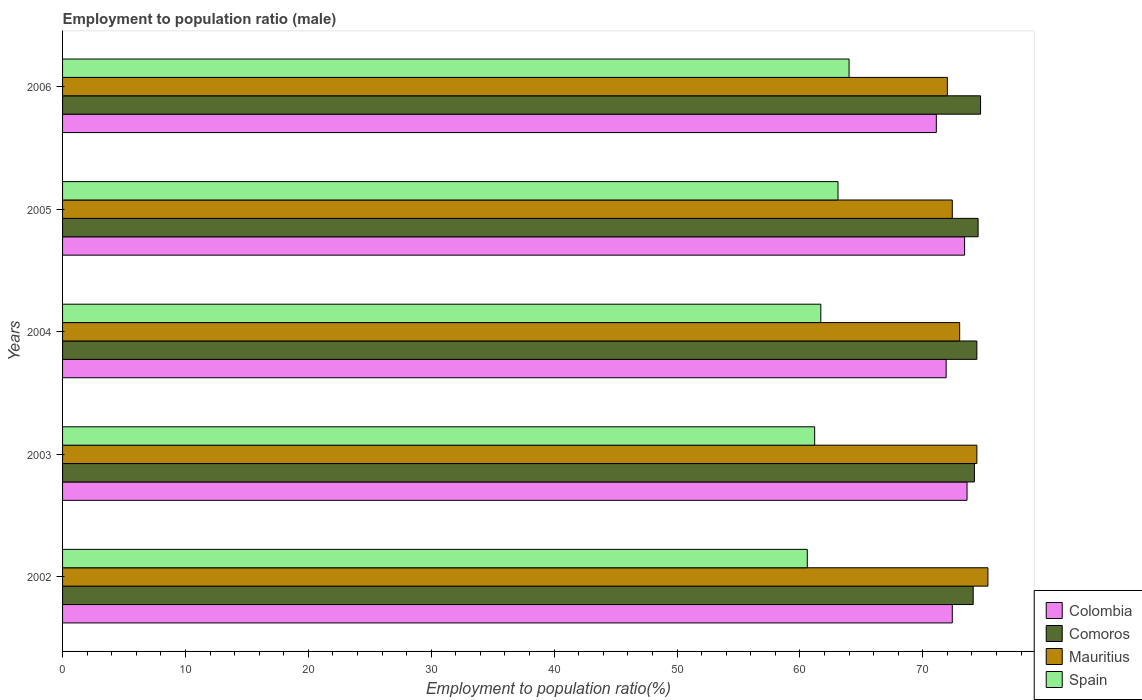How many different coloured bars are there?
Offer a terse response. 4. Are the number of bars per tick equal to the number of legend labels?
Provide a short and direct response. Yes. How many bars are there on the 2nd tick from the bottom?
Keep it short and to the point. 4. What is the label of the 1st group of bars from the top?
Provide a succinct answer. 2006. What is the employment to population ratio in Spain in 2006?
Your answer should be compact. 64. Across all years, what is the maximum employment to population ratio in Colombia?
Keep it short and to the point. 73.6. Across all years, what is the minimum employment to population ratio in Comoros?
Your answer should be compact. 74.1. In which year was the employment to population ratio in Colombia minimum?
Your response must be concise. 2006. What is the total employment to population ratio in Comoros in the graph?
Offer a very short reply. 371.9. What is the difference between the employment to population ratio in Comoros in 2004 and that in 2005?
Ensure brevity in your answer.  -0.1. What is the difference between the employment to population ratio in Mauritius in 2003 and the employment to population ratio in Spain in 2002?
Your answer should be compact. 13.8. What is the average employment to population ratio in Mauritius per year?
Your response must be concise. 73.42. In the year 2003, what is the difference between the employment to population ratio in Spain and employment to population ratio in Mauritius?
Provide a short and direct response. -13.2. What is the ratio of the employment to population ratio in Colombia in 2005 to that in 2006?
Keep it short and to the point. 1.03. Is the employment to population ratio in Mauritius in 2002 less than that in 2005?
Your answer should be compact. No. Is the difference between the employment to population ratio in Spain in 2004 and 2005 greater than the difference between the employment to population ratio in Mauritius in 2004 and 2005?
Provide a succinct answer. No. What is the difference between the highest and the second highest employment to population ratio in Mauritius?
Provide a succinct answer. 0.9. What is the difference between the highest and the lowest employment to population ratio in Comoros?
Your response must be concise. 0.6. Is it the case that in every year, the sum of the employment to population ratio in Mauritius and employment to population ratio in Spain is greater than the sum of employment to population ratio in Colombia and employment to population ratio in Comoros?
Give a very brief answer. No. What does the 3rd bar from the top in 2006 represents?
Offer a very short reply. Comoros. What does the 4th bar from the bottom in 2005 represents?
Provide a succinct answer. Spain. Are the values on the major ticks of X-axis written in scientific E-notation?
Provide a short and direct response. No. What is the title of the graph?
Your answer should be compact. Employment to population ratio (male). Does "Nigeria" appear as one of the legend labels in the graph?
Give a very brief answer. No. What is the label or title of the X-axis?
Your answer should be very brief. Employment to population ratio(%). What is the Employment to population ratio(%) in Colombia in 2002?
Offer a very short reply. 72.4. What is the Employment to population ratio(%) of Comoros in 2002?
Offer a very short reply. 74.1. What is the Employment to population ratio(%) in Mauritius in 2002?
Your answer should be compact. 75.3. What is the Employment to population ratio(%) in Spain in 2002?
Provide a short and direct response. 60.6. What is the Employment to population ratio(%) in Colombia in 2003?
Ensure brevity in your answer.  73.6. What is the Employment to population ratio(%) in Comoros in 2003?
Your response must be concise. 74.2. What is the Employment to population ratio(%) in Mauritius in 2003?
Make the answer very short. 74.4. What is the Employment to population ratio(%) in Spain in 2003?
Keep it short and to the point. 61.2. What is the Employment to population ratio(%) of Colombia in 2004?
Your response must be concise. 71.9. What is the Employment to population ratio(%) in Comoros in 2004?
Make the answer very short. 74.4. What is the Employment to population ratio(%) in Mauritius in 2004?
Make the answer very short. 73. What is the Employment to population ratio(%) of Spain in 2004?
Ensure brevity in your answer.  61.7. What is the Employment to population ratio(%) of Colombia in 2005?
Provide a succinct answer. 73.4. What is the Employment to population ratio(%) of Comoros in 2005?
Provide a short and direct response. 74.5. What is the Employment to population ratio(%) in Mauritius in 2005?
Keep it short and to the point. 72.4. What is the Employment to population ratio(%) of Spain in 2005?
Offer a very short reply. 63.1. What is the Employment to population ratio(%) in Colombia in 2006?
Your response must be concise. 71.1. What is the Employment to population ratio(%) in Comoros in 2006?
Your answer should be very brief. 74.7. What is the Employment to population ratio(%) of Mauritius in 2006?
Your response must be concise. 72. Across all years, what is the maximum Employment to population ratio(%) of Colombia?
Provide a short and direct response. 73.6. Across all years, what is the maximum Employment to population ratio(%) in Comoros?
Make the answer very short. 74.7. Across all years, what is the maximum Employment to population ratio(%) in Mauritius?
Offer a very short reply. 75.3. Across all years, what is the minimum Employment to population ratio(%) of Colombia?
Keep it short and to the point. 71.1. Across all years, what is the minimum Employment to population ratio(%) of Comoros?
Ensure brevity in your answer.  74.1. Across all years, what is the minimum Employment to population ratio(%) of Spain?
Your answer should be compact. 60.6. What is the total Employment to population ratio(%) in Colombia in the graph?
Provide a short and direct response. 362.4. What is the total Employment to population ratio(%) in Comoros in the graph?
Provide a succinct answer. 371.9. What is the total Employment to population ratio(%) of Mauritius in the graph?
Offer a terse response. 367.1. What is the total Employment to population ratio(%) in Spain in the graph?
Provide a short and direct response. 310.6. What is the difference between the Employment to population ratio(%) in Comoros in 2002 and that in 2003?
Ensure brevity in your answer.  -0.1. What is the difference between the Employment to population ratio(%) of Mauritius in 2002 and that in 2003?
Offer a very short reply. 0.9. What is the difference between the Employment to population ratio(%) of Comoros in 2002 and that in 2004?
Give a very brief answer. -0.3. What is the difference between the Employment to population ratio(%) of Mauritius in 2002 and that in 2004?
Keep it short and to the point. 2.3. What is the difference between the Employment to population ratio(%) in Comoros in 2002 and that in 2005?
Offer a terse response. -0.4. What is the difference between the Employment to population ratio(%) of Mauritius in 2002 and that in 2005?
Your response must be concise. 2.9. What is the difference between the Employment to population ratio(%) of Colombia in 2002 and that in 2006?
Make the answer very short. 1.3. What is the difference between the Employment to population ratio(%) in Spain in 2002 and that in 2006?
Ensure brevity in your answer.  -3.4. What is the difference between the Employment to population ratio(%) in Comoros in 2003 and that in 2005?
Keep it short and to the point. -0.3. What is the difference between the Employment to population ratio(%) in Comoros in 2003 and that in 2006?
Ensure brevity in your answer.  -0.5. What is the difference between the Employment to population ratio(%) in Colombia in 2004 and that in 2005?
Make the answer very short. -1.5. What is the difference between the Employment to population ratio(%) of Mauritius in 2004 and that in 2005?
Ensure brevity in your answer.  0.6. What is the difference between the Employment to population ratio(%) in Colombia in 2004 and that in 2006?
Offer a terse response. 0.8. What is the difference between the Employment to population ratio(%) in Comoros in 2004 and that in 2006?
Make the answer very short. -0.3. What is the difference between the Employment to population ratio(%) of Mauritius in 2004 and that in 2006?
Ensure brevity in your answer.  1. What is the difference between the Employment to population ratio(%) in Spain in 2004 and that in 2006?
Your answer should be very brief. -2.3. What is the difference between the Employment to population ratio(%) in Spain in 2005 and that in 2006?
Ensure brevity in your answer.  -0.9. What is the difference between the Employment to population ratio(%) of Comoros in 2002 and the Employment to population ratio(%) of Mauritius in 2003?
Offer a very short reply. -0.3. What is the difference between the Employment to population ratio(%) of Comoros in 2002 and the Employment to population ratio(%) of Spain in 2003?
Your answer should be very brief. 12.9. What is the difference between the Employment to population ratio(%) in Mauritius in 2002 and the Employment to population ratio(%) in Spain in 2003?
Your answer should be very brief. 14.1. What is the difference between the Employment to population ratio(%) in Colombia in 2002 and the Employment to population ratio(%) in Comoros in 2004?
Ensure brevity in your answer.  -2. What is the difference between the Employment to population ratio(%) of Colombia in 2002 and the Employment to population ratio(%) of Spain in 2004?
Your answer should be compact. 10.7. What is the difference between the Employment to population ratio(%) of Colombia in 2002 and the Employment to population ratio(%) of Mauritius in 2005?
Your answer should be compact. 0. What is the difference between the Employment to population ratio(%) in Colombia in 2002 and the Employment to population ratio(%) in Spain in 2005?
Offer a terse response. 9.3. What is the difference between the Employment to population ratio(%) in Mauritius in 2002 and the Employment to population ratio(%) in Spain in 2005?
Give a very brief answer. 12.2. What is the difference between the Employment to population ratio(%) in Colombia in 2002 and the Employment to population ratio(%) in Mauritius in 2006?
Provide a short and direct response. 0.4. What is the difference between the Employment to population ratio(%) of Comoros in 2002 and the Employment to population ratio(%) of Mauritius in 2006?
Give a very brief answer. 2.1. What is the difference between the Employment to population ratio(%) of Mauritius in 2002 and the Employment to population ratio(%) of Spain in 2006?
Your answer should be compact. 11.3. What is the difference between the Employment to population ratio(%) of Colombia in 2003 and the Employment to population ratio(%) of Comoros in 2004?
Provide a succinct answer. -0.8. What is the difference between the Employment to population ratio(%) of Colombia in 2003 and the Employment to population ratio(%) of Mauritius in 2004?
Give a very brief answer. 0.6. What is the difference between the Employment to population ratio(%) in Colombia in 2003 and the Employment to population ratio(%) in Spain in 2004?
Offer a very short reply. 11.9. What is the difference between the Employment to population ratio(%) in Comoros in 2003 and the Employment to population ratio(%) in Spain in 2004?
Offer a terse response. 12.5. What is the difference between the Employment to population ratio(%) of Colombia in 2003 and the Employment to population ratio(%) of Spain in 2005?
Give a very brief answer. 10.5. What is the difference between the Employment to population ratio(%) in Colombia in 2003 and the Employment to population ratio(%) in Mauritius in 2006?
Offer a very short reply. 1.6. What is the difference between the Employment to population ratio(%) of Comoros in 2003 and the Employment to population ratio(%) of Mauritius in 2006?
Keep it short and to the point. 2.2. What is the difference between the Employment to population ratio(%) in Comoros in 2003 and the Employment to population ratio(%) in Spain in 2006?
Provide a short and direct response. 10.2. What is the difference between the Employment to population ratio(%) of Mauritius in 2003 and the Employment to population ratio(%) of Spain in 2006?
Your answer should be very brief. 10.4. What is the difference between the Employment to population ratio(%) of Comoros in 2004 and the Employment to population ratio(%) of Mauritius in 2005?
Give a very brief answer. 2. What is the difference between the Employment to population ratio(%) of Comoros in 2004 and the Employment to population ratio(%) of Spain in 2005?
Offer a very short reply. 11.3. What is the difference between the Employment to population ratio(%) in Mauritius in 2004 and the Employment to population ratio(%) in Spain in 2005?
Offer a terse response. 9.9. What is the difference between the Employment to population ratio(%) of Colombia in 2004 and the Employment to population ratio(%) of Spain in 2006?
Offer a terse response. 7.9. What is the difference between the Employment to population ratio(%) of Comoros in 2004 and the Employment to population ratio(%) of Spain in 2006?
Offer a very short reply. 10.4. What is the difference between the Employment to population ratio(%) in Colombia in 2005 and the Employment to population ratio(%) in Spain in 2006?
Ensure brevity in your answer.  9.4. What is the average Employment to population ratio(%) in Colombia per year?
Offer a terse response. 72.48. What is the average Employment to population ratio(%) in Comoros per year?
Your answer should be very brief. 74.38. What is the average Employment to population ratio(%) in Mauritius per year?
Give a very brief answer. 73.42. What is the average Employment to population ratio(%) in Spain per year?
Your answer should be compact. 62.12. In the year 2002, what is the difference between the Employment to population ratio(%) of Colombia and Employment to population ratio(%) of Mauritius?
Offer a terse response. -2.9. In the year 2002, what is the difference between the Employment to population ratio(%) in Mauritius and Employment to population ratio(%) in Spain?
Provide a short and direct response. 14.7. In the year 2003, what is the difference between the Employment to population ratio(%) in Comoros and Employment to population ratio(%) in Spain?
Provide a short and direct response. 13. In the year 2003, what is the difference between the Employment to population ratio(%) of Mauritius and Employment to population ratio(%) of Spain?
Offer a very short reply. 13.2. In the year 2004, what is the difference between the Employment to population ratio(%) of Comoros and Employment to population ratio(%) of Mauritius?
Your response must be concise. 1.4. In the year 2004, what is the difference between the Employment to population ratio(%) of Comoros and Employment to population ratio(%) of Spain?
Give a very brief answer. 12.7. In the year 2004, what is the difference between the Employment to population ratio(%) in Mauritius and Employment to population ratio(%) in Spain?
Your response must be concise. 11.3. In the year 2005, what is the difference between the Employment to population ratio(%) in Colombia and Employment to population ratio(%) in Mauritius?
Ensure brevity in your answer.  1. In the year 2005, what is the difference between the Employment to population ratio(%) of Comoros and Employment to population ratio(%) of Mauritius?
Make the answer very short. 2.1. In the year 2006, what is the difference between the Employment to population ratio(%) of Colombia and Employment to population ratio(%) of Comoros?
Keep it short and to the point. -3.6. In the year 2006, what is the difference between the Employment to population ratio(%) in Colombia and Employment to population ratio(%) in Mauritius?
Your answer should be very brief. -0.9. In the year 2006, what is the difference between the Employment to population ratio(%) of Colombia and Employment to population ratio(%) of Spain?
Provide a short and direct response. 7.1. In the year 2006, what is the difference between the Employment to population ratio(%) in Comoros and Employment to population ratio(%) in Mauritius?
Give a very brief answer. 2.7. What is the ratio of the Employment to population ratio(%) of Colombia in 2002 to that in 2003?
Your response must be concise. 0.98. What is the ratio of the Employment to population ratio(%) in Mauritius in 2002 to that in 2003?
Ensure brevity in your answer.  1.01. What is the ratio of the Employment to population ratio(%) in Spain in 2002 to that in 2003?
Offer a very short reply. 0.99. What is the ratio of the Employment to population ratio(%) of Mauritius in 2002 to that in 2004?
Make the answer very short. 1.03. What is the ratio of the Employment to population ratio(%) in Spain in 2002 to that in 2004?
Keep it short and to the point. 0.98. What is the ratio of the Employment to population ratio(%) of Colombia in 2002 to that in 2005?
Give a very brief answer. 0.99. What is the ratio of the Employment to population ratio(%) of Comoros in 2002 to that in 2005?
Give a very brief answer. 0.99. What is the ratio of the Employment to population ratio(%) in Mauritius in 2002 to that in 2005?
Offer a very short reply. 1.04. What is the ratio of the Employment to population ratio(%) of Spain in 2002 to that in 2005?
Offer a terse response. 0.96. What is the ratio of the Employment to population ratio(%) in Colombia in 2002 to that in 2006?
Your answer should be compact. 1.02. What is the ratio of the Employment to population ratio(%) in Comoros in 2002 to that in 2006?
Your response must be concise. 0.99. What is the ratio of the Employment to population ratio(%) in Mauritius in 2002 to that in 2006?
Keep it short and to the point. 1.05. What is the ratio of the Employment to population ratio(%) of Spain in 2002 to that in 2006?
Offer a terse response. 0.95. What is the ratio of the Employment to population ratio(%) in Colombia in 2003 to that in 2004?
Offer a very short reply. 1.02. What is the ratio of the Employment to population ratio(%) in Comoros in 2003 to that in 2004?
Your response must be concise. 1. What is the ratio of the Employment to population ratio(%) in Mauritius in 2003 to that in 2004?
Provide a short and direct response. 1.02. What is the ratio of the Employment to population ratio(%) in Spain in 2003 to that in 2004?
Provide a succinct answer. 0.99. What is the ratio of the Employment to population ratio(%) in Comoros in 2003 to that in 2005?
Ensure brevity in your answer.  1. What is the ratio of the Employment to population ratio(%) of Mauritius in 2003 to that in 2005?
Your response must be concise. 1.03. What is the ratio of the Employment to population ratio(%) in Spain in 2003 to that in 2005?
Provide a short and direct response. 0.97. What is the ratio of the Employment to population ratio(%) of Colombia in 2003 to that in 2006?
Give a very brief answer. 1.04. What is the ratio of the Employment to population ratio(%) of Comoros in 2003 to that in 2006?
Your answer should be very brief. 0.99. What is the ratio of the Employment to population ratio(%) of Spain in 2003 to that in 2006?
Provide a succinct answer. 0.96. What is the ratio of the Employment to population ratio(%) of Colombia in 2004 to that in 2005?
Your answer should be very brief. 0.98. What is the ratio of the Employment to population ratio(%) of Comoros in 2004 to that in 2005?
Offer a very short reply. 1. What is the ratio of the Employment to population ratio(%) in Mauritius in 2004 to that in 2005?
Make the answer very short. 1.01. What is the ratio of the Employment to population ratio(%) of Spain in 2004 to that in 2005?
Your answer should be compact. 0.98. What is the ratio of the Employment to population ratio(%) of Colombia in 2004 to that in 2006?
Provide a succinct answer. 1.01. What is the ratio of the Employment to population ratio(%) of Comoros in 2004 to that in 2006?
Give a very brief answer. 1. What is the ratio of the Employment to population ratio(%) in Mauritius in 2004 to that in 2006?
Make the answer very short. 1.01. What is the ratio of the Employment to population ratio(%) in Spain in 2004 to that in 2006?
Your answer should be compact. 0.96. What is the ratio of the Employment to population ratio(%) of Colombia in 2005 to that in 2006?
Offer a terse response. 1.03. What is the ratio of the Employment to population ratio(%) of Mauritius in 2005 to that in 2006?
Your response must be concise. 1.01. What is the ratio of the Employment to population ratio(%) in Spain in 2005 to that in 2006?
Provide a short and direct response. 0.99. What is the difference between the highest and the second highest Employment to population ratio(%) of Mauritius?
Your answer should be very brief. 0.9. What is the difference between the highest and the lowest Employment to population ratio(%) of Spain?
Offer a terse response. 3.4. 